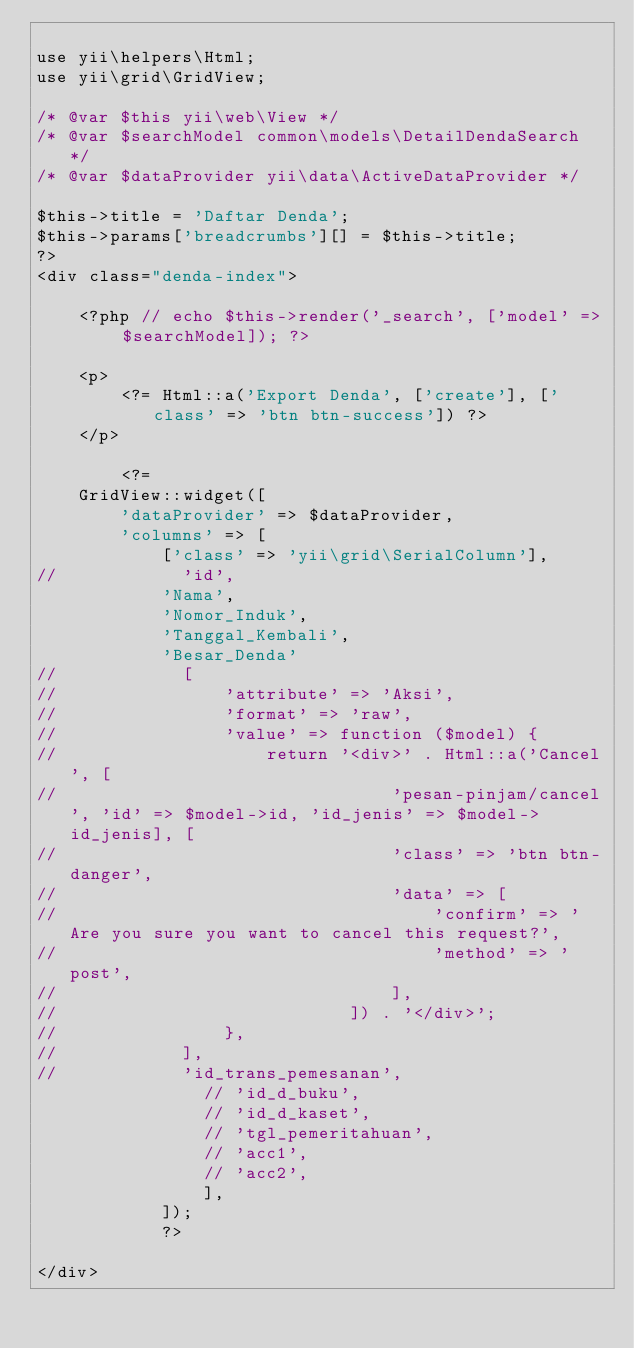<code> <loc_0><loc_0><loc_500><loc_500><_PHP_>
use yii\helpers\Html;
use yii\grid\GridView;

/* @var $this yii\web\View */
/* @var $searchModel common\models\DetailDendaSearch */
/* @var $dataProvider yii\data\ActiveDataProvider */

$this->title = 'Daftar Denda';
$this->params['breadcrumbs'][] = $this->title;
?>
<div class="denda-index">

    <?php // echo $this->render('_search', ['model' => $searchModel]); ?>

    <p>
        <?= Html::a('Export Denda', ['create'], ['class' => 'btn btn-success']) ?>
    </p>

        <?=
    GridView::widget([
        'dataProvider' => $dataProvider,
        'columns' => [
            ['class' => 'yii\grid\SerialColumn'],
//            'id',
            'Nama',
            'Nomor_Induk',
            'Tanggal_Kembali',
            'Besar_Denda'
//            [
//                'attribute' => 'Aksi',
//                'format' => 'raw',
//                'value' => function ($model) {
//                    return '<div>' . Html::a('Cancel', [
//                                'pesan-pinjam/cancel', 'id' => $model->id, 'id_jenis' => $model->id_jenis], [
//                                'class' => 'btn btn-danger',
//                                'data' => [
//                                    'confirm' => 'Are you sure you want to cancel this request?',
//                                    'method' => 'post',
//                                ],
//                            ]) . '</div>';
//                },
//            ],
//            'id_trans_pemesanan',
                // 'id_d_buku',
                // 'id_d_kaset',
                // 'tgl_pemeritahuan',
                // 'acc1',
                // 'acc2',
                ],
            ]);
            ?>

</div>
</code> 